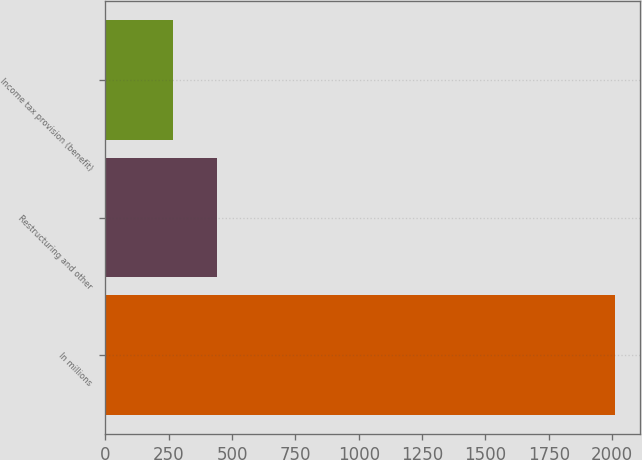Convert chart to OTSL. <chart><loc_0><loc_0><loc_500><loc_500><bar_chart><fcel>In millions<fcel>Restructuring and other<fcel>Income tax provision (benefit)<nl><fcel>2011<fcel>440.5<fcel>266<nl></chart> 